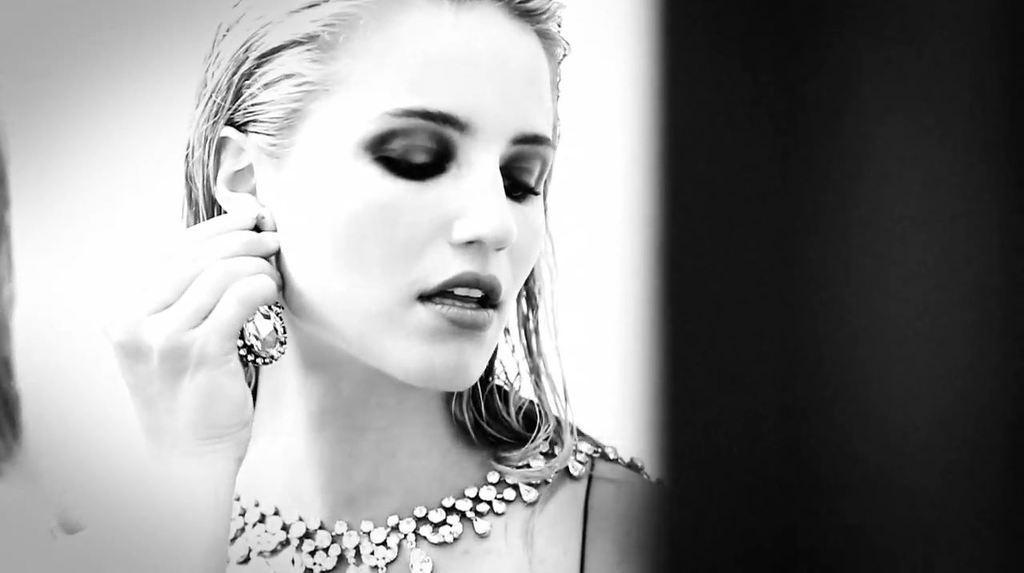How would you summarize this image in a sentence or two? In this image there is a woman in the center holding a earring. 